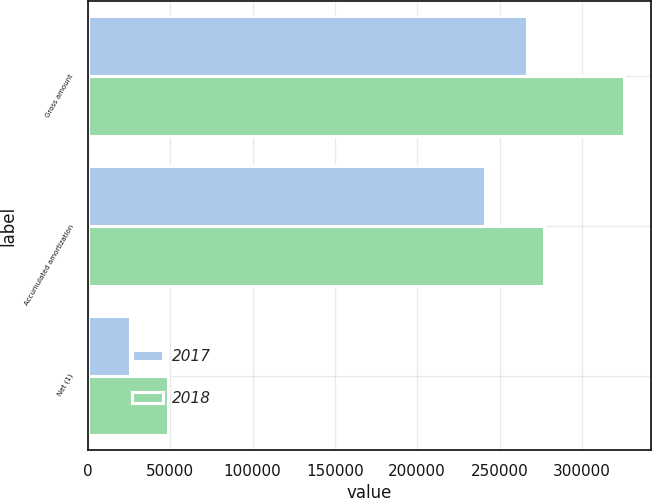Convert chart. <chart><loc_0><loc_0><loc_500><loc_500><stacked_bar_chart><ecel><fcel>Gross amount<fcel>Accumulated amortization<fcel>Net (1)<nl><fcel>2017<fcel>266540<fcel>241040<fcel>25500<nl><fcel>2018<fcel>325880<fcel>277038<fcel>48842<nl></chart> 